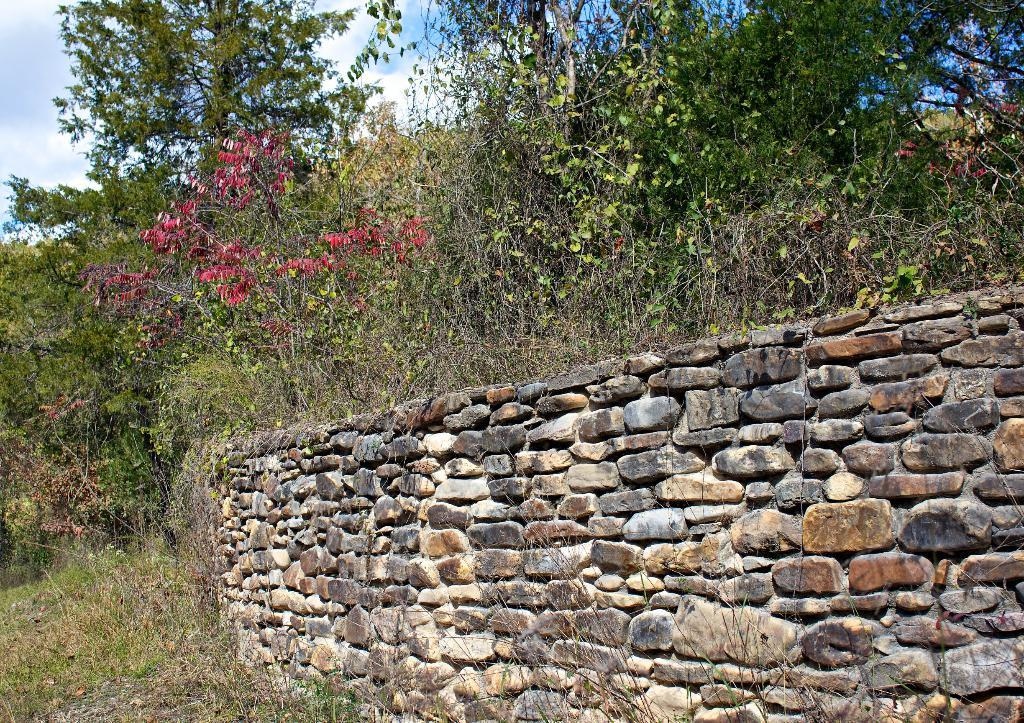What type of wall is shown in the image? There is a wall built with stones in the image. What kind of plants can be seen in the image? There is a group of plants with flowers in the image. What other natural elements are present in the image? There are trees in the image. How would you describe the sky in the image? The sky is visible in the image and appears cloudy. What type of pipe is visible in the image? There is no pipe present in the image. What country is the image taken in? The provided facts do not mention the country where the image was taken. 